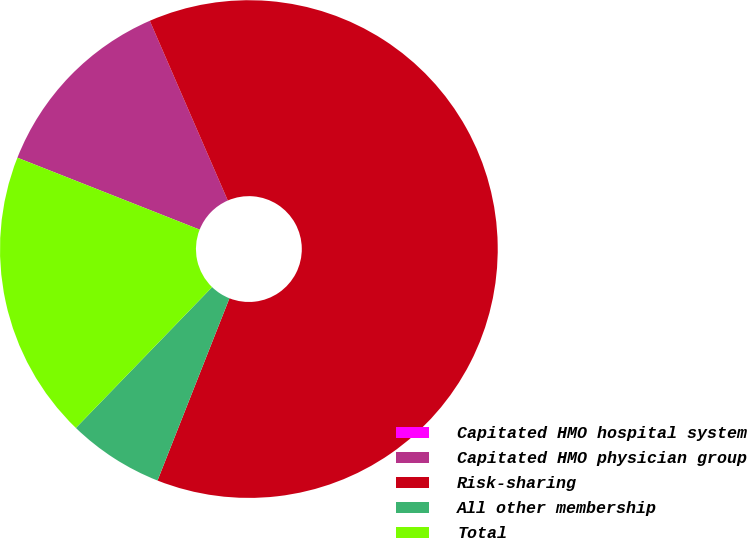Convert chart to OTSL. <chart><loc_0><loc_0><loc_500><loc_500><pie_chart><fcel>Capitated HMO hospital system<fcel>Capitated HMO physician group<fcel>Risk-sharing<fcel>All other membership<fcel>Total<nl><fcel>0.0%<fcel>12.5%<fcel>62.5%<fcel>6.25%<fcel>18.75%<nl></chart> 